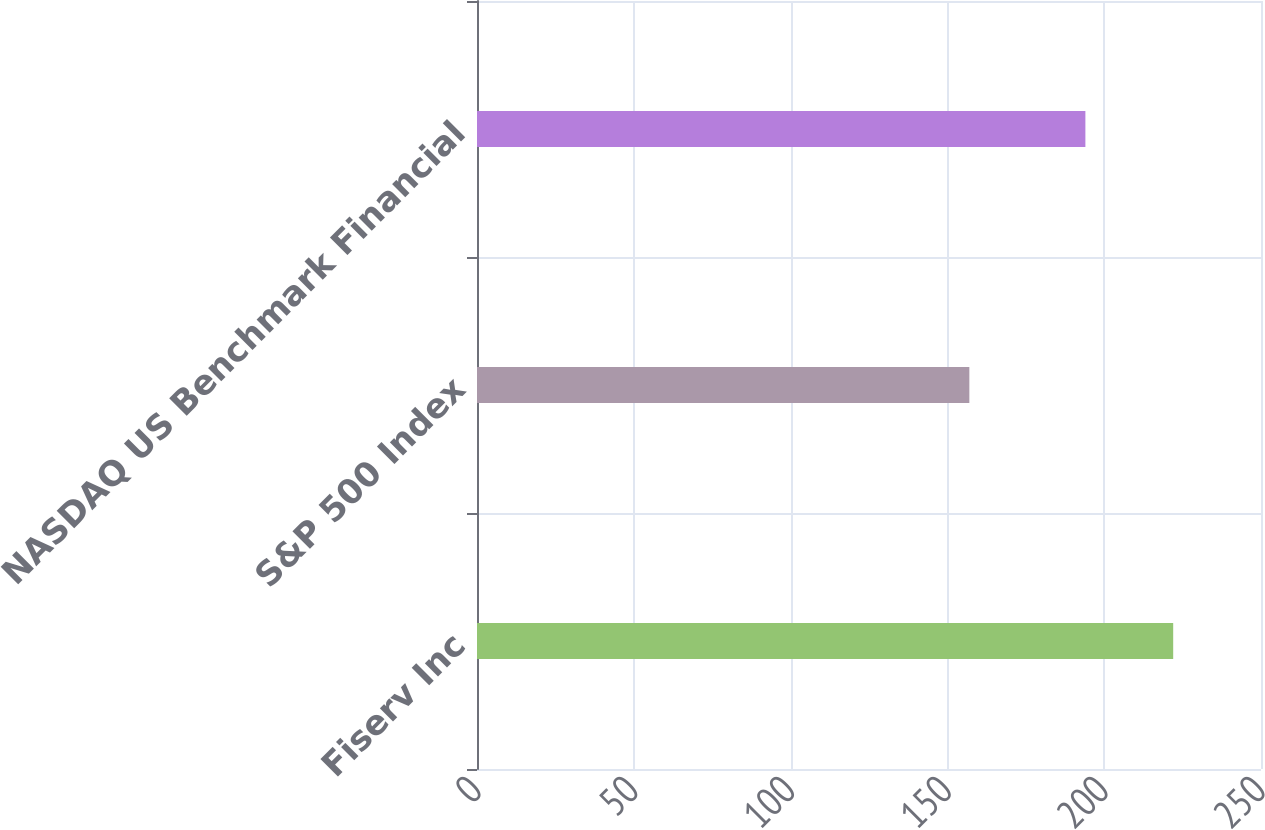Convert chart. <chart><loc_0><loc_0><loc_500><loc_500><bar_chart><fcel>Fiserv Inc<fcel>S&P 500 Index<fcel>NASDAQ US Benchmark Financial<nl><fcel>222<fcel>157<fcel>194<nl></chart> 